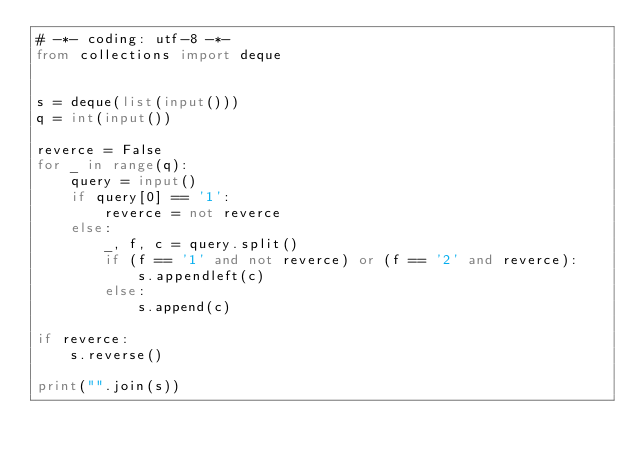Convert code to text. <code><loc_0><loc_0><loc_500><loc_500><_Python_># -*- coding: utf-8 -*-
from collections import deque


s = deque(list(input()))
q = int(input())

reverce = False
for _ in range(q):
    query = input()
    if query[0] == '1':
        reverce = not reverce
    else:
        _, f, c = query.split()
        if (f == '1' and not reverce) or (f == '2' and reverce):
            s.appendleft(c)
        else:
            s.append(c)

if reverce:
    s.reverse()

print("".join(s))
</code> 